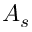<formula> <loc_0><loc_0><loc_500><loc_500>A _ { s }</formula> 